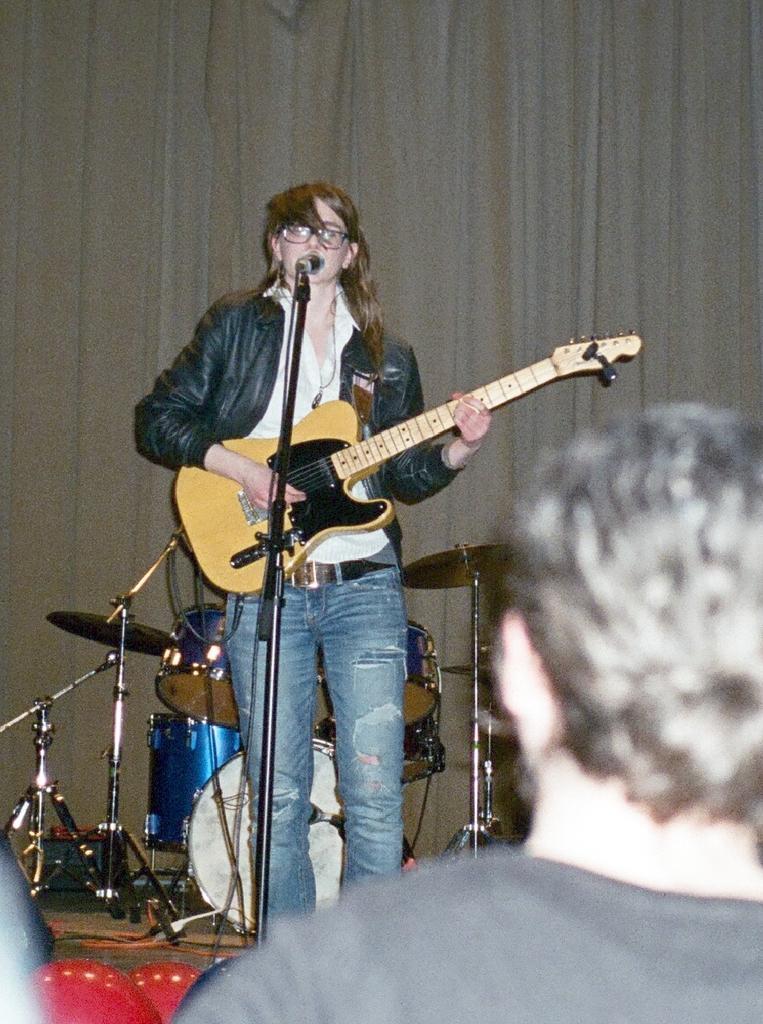In one or two sentences, can you explain what this image depicts? In this image I can see you two people where one is standing and holding a guitar. I can also see she is wearing a specs, jacket and jeans. I can also see a mic in front of her and in the background I can see a drum set. 